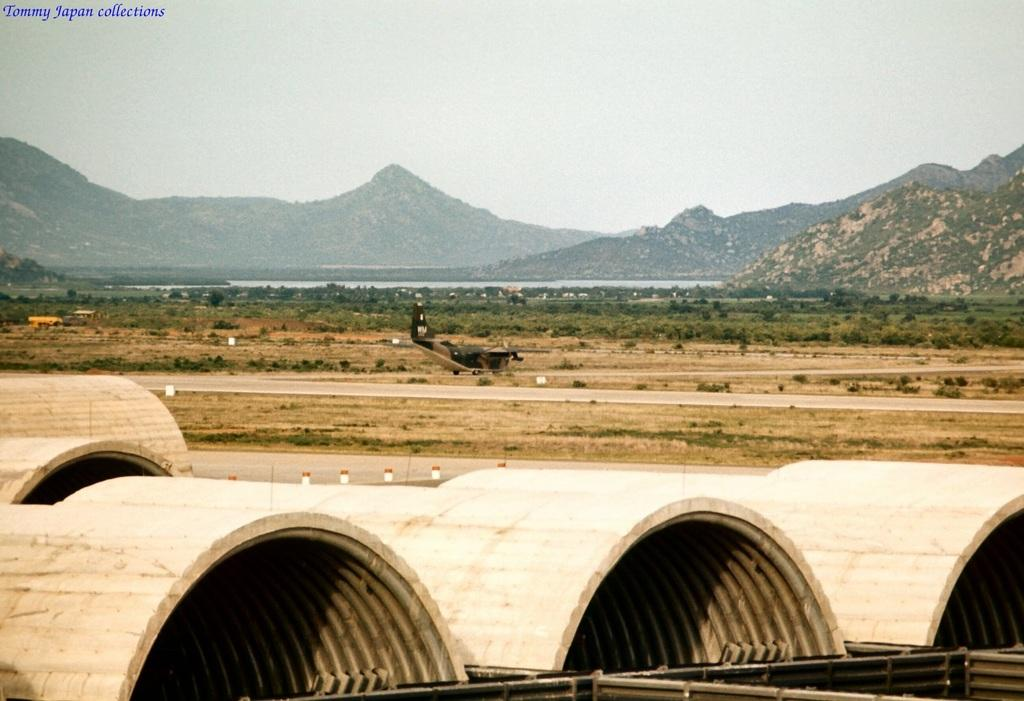What type of objects can be seen in the image? There are objects that look like cement pipes in the image. What can be seen in the background of the image? There is an airplane, trees, mountains, and the sky visible in the background of the image. How many kittens are sitting on the foot of the cement pipes in the image? There are no kittens or feet of cement pipes present in the image. 